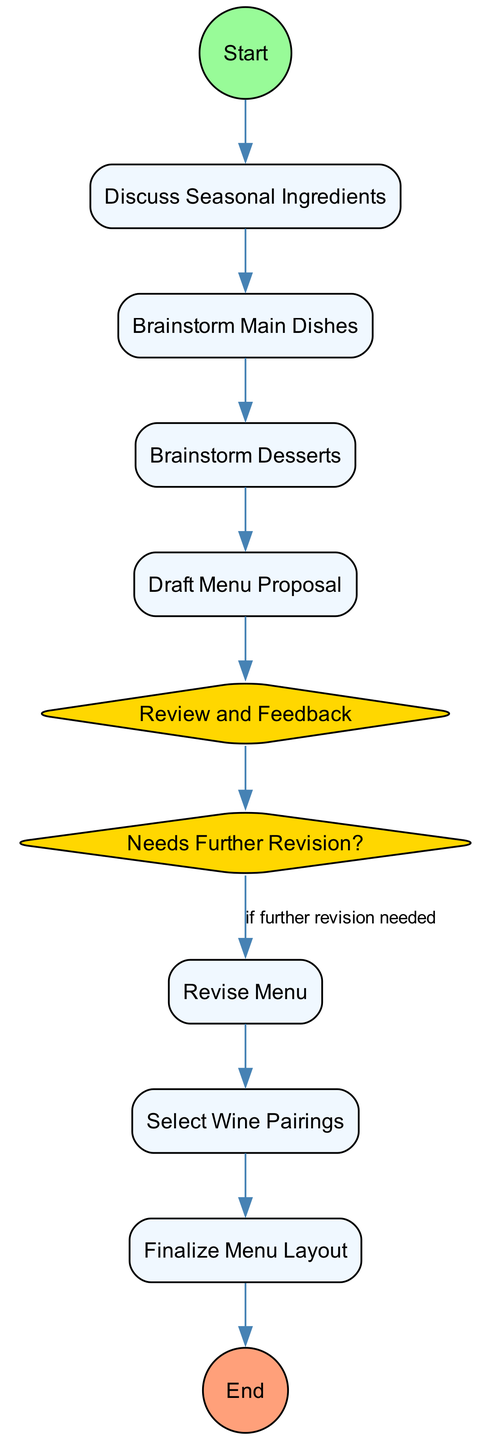What is the first activity listed in the diagram? The first activity after the "Initiate Collaboration" start event is "Discuss Seasonal Ingredients," which directly follows it.
Answer: Discuss Seasonal Ingredients How many decision points are there in the diagram? The diagram contains two decision points: "Review and Feedback" and "Needs Further Revision?" totaling both as decision nodes.
Answer: 2 What activity follows the "Brainstorm Desserts" activity? After "Brainstorm Desserts," the next activity is "Draft Menu Proposal," which is the subsequent step in the flow.
Answer: Draft Menu Proposal Which activity is conditional based on a decision point? The "Revise Menu" activity is conditional upon the decision point "Needs Further Revision?" indicating that this step depends on feedback about the draft menu.
Answer: Revise Menu What is the final event in the diagram? The final event in the diagram is "Menu Ready for Presentation," which signifies the completion of the entire process outlined in the activity diagram.
Answer: Menu Ready for Presentation In what order do the main dishes and desserts get brainstormed? The order is first "Brainstorm Main Dishes" followed by "Brainstorm Desserts," indicating the sequence of idea generation for the menu.
Answer: Main Dishes, Desserts Which activity represents the selection of beverage pairings? The activity that represents beverage selection is "Select Wine Pairings," which is included in the collaborative process to enhance the menu.
Answer: Select Wine Pairings What decision needs to be made after the draft menu is prepared? After the draft menu is prepared, the decision is whether it "Needs Further Revision?" to determine if more changes are necessary.
Answer: Needs Further Revision How many activities are present in the diagram? There are eight activities present in total, encompassing all main tasks described throughout the collaboration process in the menu design.
Answer: 8 